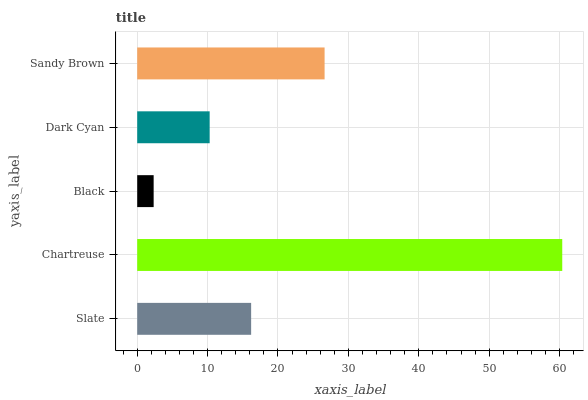Is Black the minimum?
Answer yes or no. Yes. Is Chartreuse the maximum?
Answer yes or no. Yes. Is Chartreuse the minimum?
Answer yes or no. No. Is Black the maximum?
Answer yes or no. No. Is Chartreuse greater than Black?
Answer yes or no. Yes. Is Black less than Chartreuse?
Answer yes or no. Yes. Is Black greater than Chartreuse?
Answer yes or no. No. Is Chartreuse less than Black?
Answer yes or no. No. Is Slate the high median?
Answer yes or no. Yes. Is Slate the low median?
Answer yes or no. Yes. Is Chartreuse the high median?
Answer yes or no. No. Is Sandy Brown the low median?
Answer yes or no. No. 